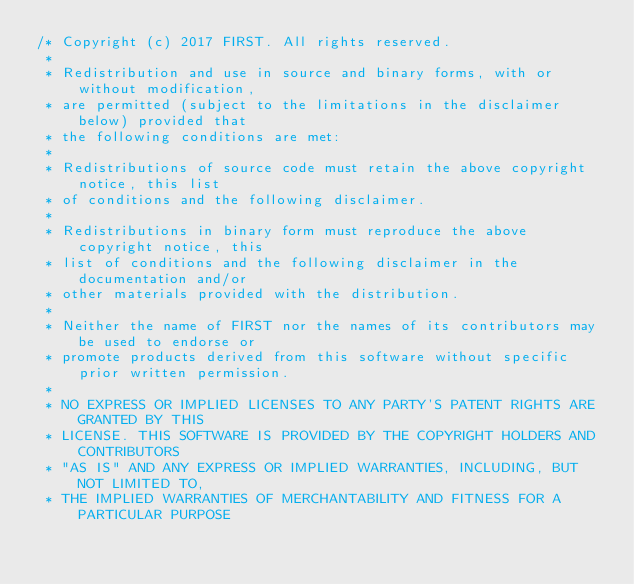<code> <loc_0><loc_0><loc_500><loc_500><_Java_>/* Copyright (c) 2017 FIRST. All rights reserved.
 *
 * Redistribution and use in source and binary forms, with or without modification,
 * are permitted (subject to the limitations in the disclaimer below) provided that
 * the following conditions are met:
 *
 * Redistributions of source code must retain the above copyright notice, this list
 * of conditions and the following disclaimer.
 *
 * Redistributions in binary form must reproduce the above copyright notice, this
 * list of conditions and the following disclaimer in the documentation and/or
 * other materials provided with the distribution.
 *
 * Neither the name of FIRST nor the names of its contributors may be used to endorse or
 * promote products derived from this software without specific prior written permission.
 *
 * NO EXPRESS OR IMPLIED LICENSES TO ANY PARTY'S PATENT RIGHTS ARE GRANTED BY THIS
 * LICENSE. THIS SOFTWARE IS PROVIDED BY THE COPYRIGHT HOLDERS AND CONTRIBUTORS
 * "AS IS" AND ANY EXPRESS OR IMPLIED WARRANTIES, INCLUDING, BUT NOT LIMITED TO,
 * THE IMPLIED WARRANTIES OF MERCHANTABILITY AND FITNESS FOR A PARTICULAR PURPOSE</code> 